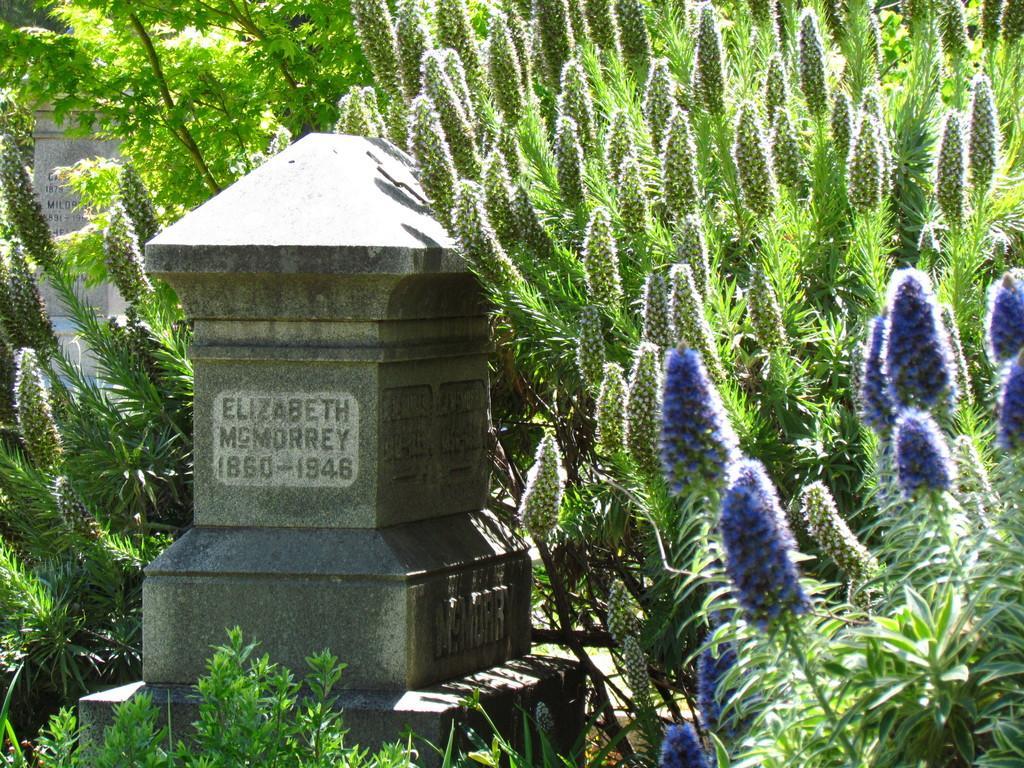How would you summarize this image in a sentence or two? This image is taken outdoors. In the middle of the image there is a tombstone with a text on it. In this image there are many plants with leaves, stems and flowers. In the background there is a wall with a text on it. 